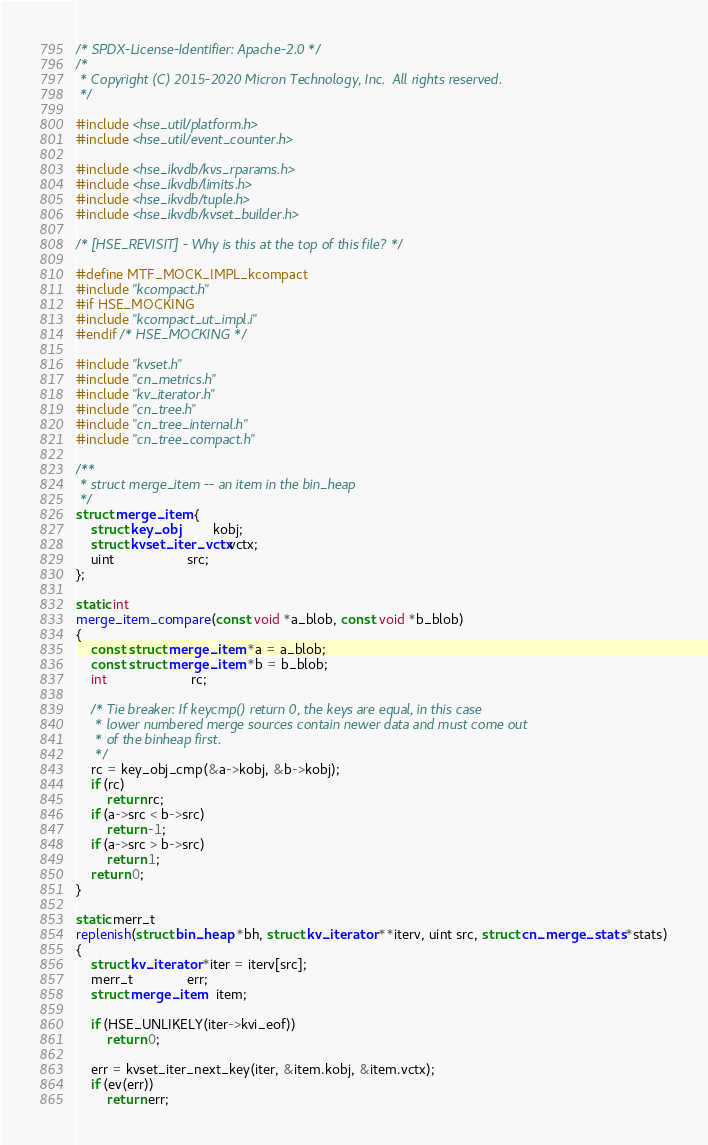<code> <loc_0><loc_0><loc_500><loc_500><_C_>/* SPDX-License-Identifier: Apache-2.0 */
/*
 * Copyright (C) 2015-2020 Micron Technology, Inc.  All rights reserved.
 */

#include <hse_util/platform.h>
#include <hse_util/event_counter.h>

#include <hse_ikvdb/kvs_rparams.h>
#include <hse_ikvdb/limits.h>
#include <hse_ikvdb/tuple.h>
#include <hse_ikvdb/kvset_builder.h>

/* [HSE_REVISIT] - Why is this at the top of this file? */

#define MTF_MOCK_IMPL_kcompact
#include "kcompact.h"
#if HSE_MOCKING
#include "kcompact_ut_impl.i"
#endif /* HSE_MOCKING */

#include "kvset.h"
#include "cn_metrics.h"
#include "kv_iterator.h"
#include "cn_tree.h"
#include "cn_tree_internal.h"
#include "cn_tree_compact.h"

/**
 * struct merge_item -- an item in the bin_heap
 */
struct merge_item {
    struct key_obj         kobj;
    struct kvset_iter_vctx vctx;
    uint                   src;
};

static int
merge_item_compare(const void *a_blob, const void *b_blob)
{
    const struct merge_item *a = a_blob;
    const struct merge_item *b = b_blob;
    int                      rc;

    /* Tie breaker: If keycmp() return 0, the keys are equal, in this case
     * lower numbered merge sources contain newer data and must come out
     * of the binheap first.
     */
    rc = key_obj_cmp(&a->kobj, &b->kobj);
    if (rc)
        return rc;
    if (a->src < b->src)
        return -1;
    if (a->src > b->src)
        return 1;
    return 0;
}

static merr_t
replenish(struct bin_heap *bh, struct kv_iterator **iterv, uint src, struct cn_merge_stats *stats)
{
    struct kv_iterator *iter = iterv[src];
    merr_t              err;
    struct merge_item   item;

    if (HSE_UNLIKELY(iter->kvi_eof))
        return 0;

    err = kvset_iter_next_key(iter, &item.kobj, &item.vctx);
    if (ev(err))
        return err;</code> 